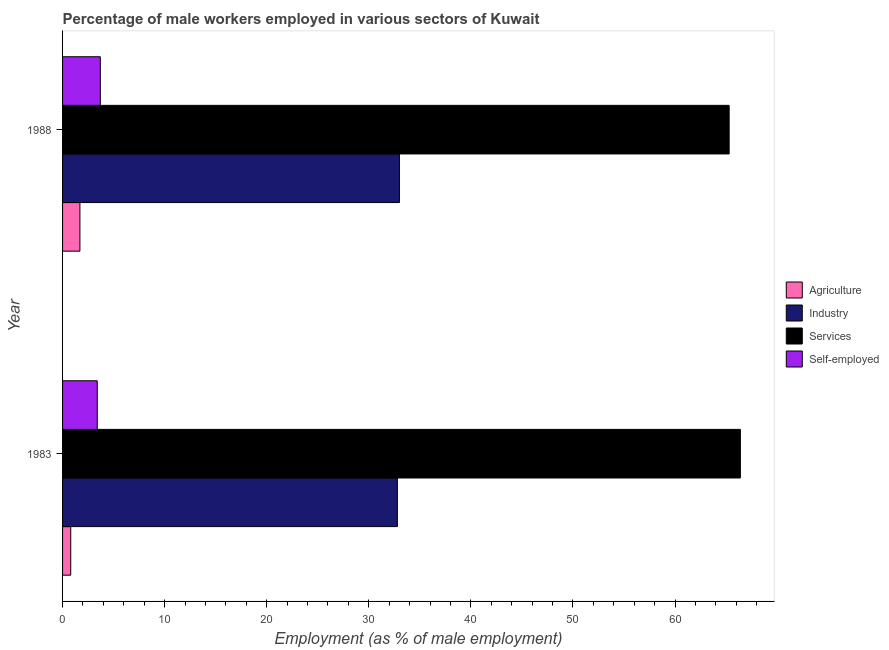Are the number of bars on each tick of the Y-axis equal?
Ensure brevity in your answer.  Yes. How many bars are there on the 2nd tick from the top?
Provide a short and direct response. 4. What is the label of the 2nd group of bars from the top?
Ensure brevity in your answer.  1983. In how many cases, is the number of bars for a given year not equal to the number of legend labels?
Your answer should be compact. 0. What is the percentage of male workers in agriculture in 1983?
Make the answer very short. 0.8. Across all years, what is the maximum percentage of male workers in industry?
Ensure brevity in your answer.  33. Across all years, what is the minimum percentage of male workers in services?
Your answer should be compact. 65.3. In which year was the percentage of self employed male workers maximum?
Your answer should be compact. 1988. What is the total percentage of male workers in industry in the graph?
Keep it short and to the point. 65.8. What is the difference between the percentage of male workers in industry in 1983 and that in 1988?
Provide a short and direct response. -0.2. What is the difference between the percentage of male workers in services in 1988 and the percentage of male workers in agriculture in 1983?
Offer a terse response. 64.5. What is the average percentage of male workers in agriculture per year?
Your answer should be very brief. 1.25. In how many years, is the percentage of male workers in industry greater than 54 %?
Your answer should be very brief. 0. What is the ratio of the percentage of male workers in industry in 1983 to that in 1988?
Ensure brevity in your answer.  0.99. Is the percentage of male workers in industry in 1983 less than that in 1988?
Provide a short and direct response. Yes. What does the 1st bar from the top in 1983 represents?
Provide a short and direct response. Self-employed. What does the 3rd bar from the bottom in 1988 represents?
Your response must be concise. Services. Is it the case that in every year, the sum of the percentage of male workers in agriculture and percentage of male workers in industry is greater than the percentage of male workers in services?
Your answer should be compact. No. How many bars are there?
Give a very brief answer. 8. How many years are there in the graph?
Ensure brevity in your answer.  2. Are the values on the major ticks of X-axis written in scientific E-notation?
Your answer should be very brief. No. Does the graph contain any zero values?
Offer a very short reply. No. Does the graph contain grids?
Make the answer very short. No. Where does the legend appear in the graph?
Your response must be concise. Center right. What is the title of the graph?
Keep it short and to the point. Percentage of male workers employed in various sectors of Kuwait. Does "Social Awareness" appear as one of the legend labels in the graph?
Make the answer very short. No. What is the label or title of the X-axis?
Your answer should be very brief. Employment (as % of male employment). What is the label or title of the Y-axis?
Provide a succinct answer. Year. What is the Employment (as % of male employment) of Agriculture in 1983?
Your answer should be compact. 0.8. What is the Employment (as % of male employment) of Industry in 1983?
Offer a very short reply. 32.8. What is the Employment (as % of male employment) of Services in 1983?
Your response must be concise. 66.4. What is the Employment (as % of male employment) in Self-employed in 1983?
Ensure brevity in your answer.  3.4. What is the Employment (as % of male employment) of Agriculture in 1988?
Make the answer very short. 1.7. What is the Employment (as % of male employment) of Services in 1988?
Your answer should be very brief. 65.3. What is the Employment (as % of male employment) in Self-employed in 1988?
Your answer should be compact. 3.7. Across all years, what is the maximum Employment (as % of male employment) of Agriculture?
Your answer should be very brief. 1.7. Across all years, what is the maximum Employment (as % of male employment) in Services?
Your response must be concise. 66.4. Across all years, what is the maximum Employment (as % of male employment) of Self-employed?
Your response must be concise. 3.7. Across all years, what is the minimum Employment (as % of male employment) of Agriculture?
Make the answer very short. 0.8. Across all years, what is the minimum Employment (as % of male employment) of Industry?
Keep it short and to the point. 32.8. Across all years, what is the minimum Employment (as % of male employment) of Services?
Your answer should be very brief. 65.3. Across all years, what is the minimum Employment (as % of male employment) of Self-employed?
Make the answer very short. 3.4. What is the total Employment (as % of male employment) in Industry in the graph?
Give a very brief answer. 65.8. What is the total Employment (as % of male employment) in Services in the graph?
Your response must be concise. 131.7. What is the difference between the Employment (as % of male employment) of Agriculture in 1983 and that in 1988?
Your response must be concise. -0.9. What is the difference between the Employment (as % of male employment) in Industry in 1983 and that in 1988?
Your answer should be compact. -0.2. What is the difference between the Employment (as % of male employment) in Agriculture in 1983 and the Employment (as % of male employment) in Industry in 1988?
Offer a terse response. -32.2. What is the difference between the Employment (as % of male employment) in Agriculture in 1983 and the Employment (as % of male employment) in Services in 1988?
Provide a short and direct response. -64.5. What is the difference between the Employment (as % of male employment) of Industry in 1983 and the Employment (as % of male employment) of Services in 1988?
Provide a succinct answer. -32.5. What is the difference between the Employment (as % of male employment) in Industry in 1983 and the Employment (as % of male employment) in Self-employed in 1988?
Your answer should be very brief. 29.1. What is the difference between the Employment (as % of male employment) of Services in 1983 and the Employment (as % of male employment) of Self-employed in 1988?
Keep it short and to the point. 62.7. What is the average Employment (as % of male employment) in Industry per year?
Your response must be concise. 32.9. What is the average Employment (as % of male employment) in Services per year?
Offer a terse response. 65.85. What is the average Employment (as % of male employment) of Self-employed per year?
Provide a succinct answer. 3.55. In the year 1983, what is the difference between the Employment (as % of male employment) of Agriculture and Employment (as % of male employment) of Industry?
Give a very brief answer. -32. In the year 1983, what is the difference between the Employment (as % of male employment) of Agriculture and Employment (as % of male employment) of Services?
Offer a terse response. -65.6. In the year 1983, what is the difference between the Employment (as % of male employment) of Agriculture and Employment (as % of male employment) of Self-employed?
Ensure brevity in your answer.  -2.6. In the year 1983, what is the difference between the Employment (as % of male employment) in Industry and Employment (as % of male employment) in Services?
Make the answer very short. -33.6. In the year 1983, what is the difference between the Employment (as % of male employment) of Industry and Employment (as % of male employment) of Self-employed?
Offer a terse response. 29.4. In the year 1988, what is the difference between the Employment (as % of male employment) in Agriculture and Employment (as % of male employment) in Industry?
Keep it short and to the point. -31.3. In the year 1988, what is the difference between the Employment (as % of male employment) of Agriculture and Employment (as % of male employment) of Services?
Your response must be concise. -63.6. In the year 1988, what is the difference between the Employment (as % of male employment) in Industry and Employment (as % of male employment) in Services?
Give a very brief answer. -32.3. In the year 1988, what is the difference between the Employment (as % of male employment) of Industry and Employment (as % of male employment) of Self-employed?
Make the answer very short. 29.3. In the year 1988, what is the difference between the Employment (as % of male employment) in Services and Employment (as % of male employment) in Self-employed?
Provide a short and direct response. 61.6. What is the ratio of the Employment (as % of male employment) of Agriculture in 1983 to that in 1988?
Ensure brevity in your answer.  0.47. What is the ratio of the Employment (as % of male employment) of Services in 1983 to that in 1988?
Provide a succinct answer. 1.02. What is the ratio of the Employment (as % of male employment) in Self-employed in 1983 to that in 1988?
Make the answer very short. 0.92. What is the difference between the highest and the second highest Employment (as % of male employment) in Industry?
Your response must be concise. 0.2. What is the difference between the highest and the second highest Employment (as % of male employment) in Services?
Your answer should be very brief. 1.1. What is the difference between the highest and the lowest Employment (as % of male employment) in Services?
Offer a terse response. 1.1. What is the difference between the highest and the lowest Employment (as % of male employment) in Self-employed?
Provide a succinct answer. 0.3. 